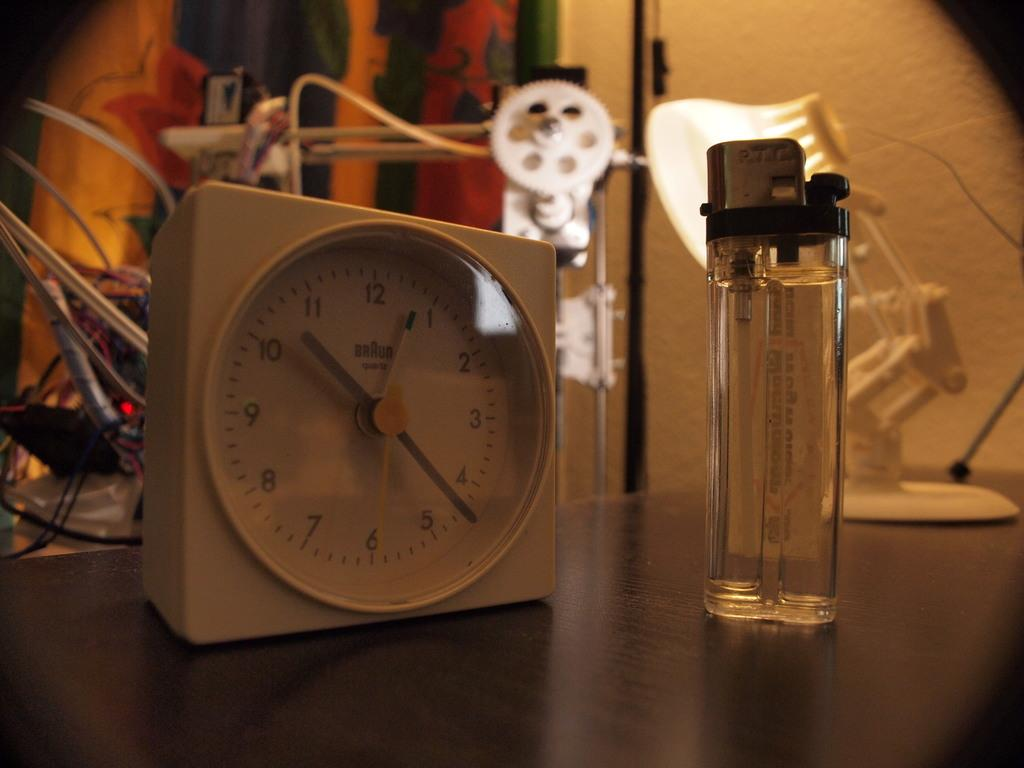<image>
Give a short and clear explanation of the subsequent image. A Braun Quartz clock sitting next to a lighter 